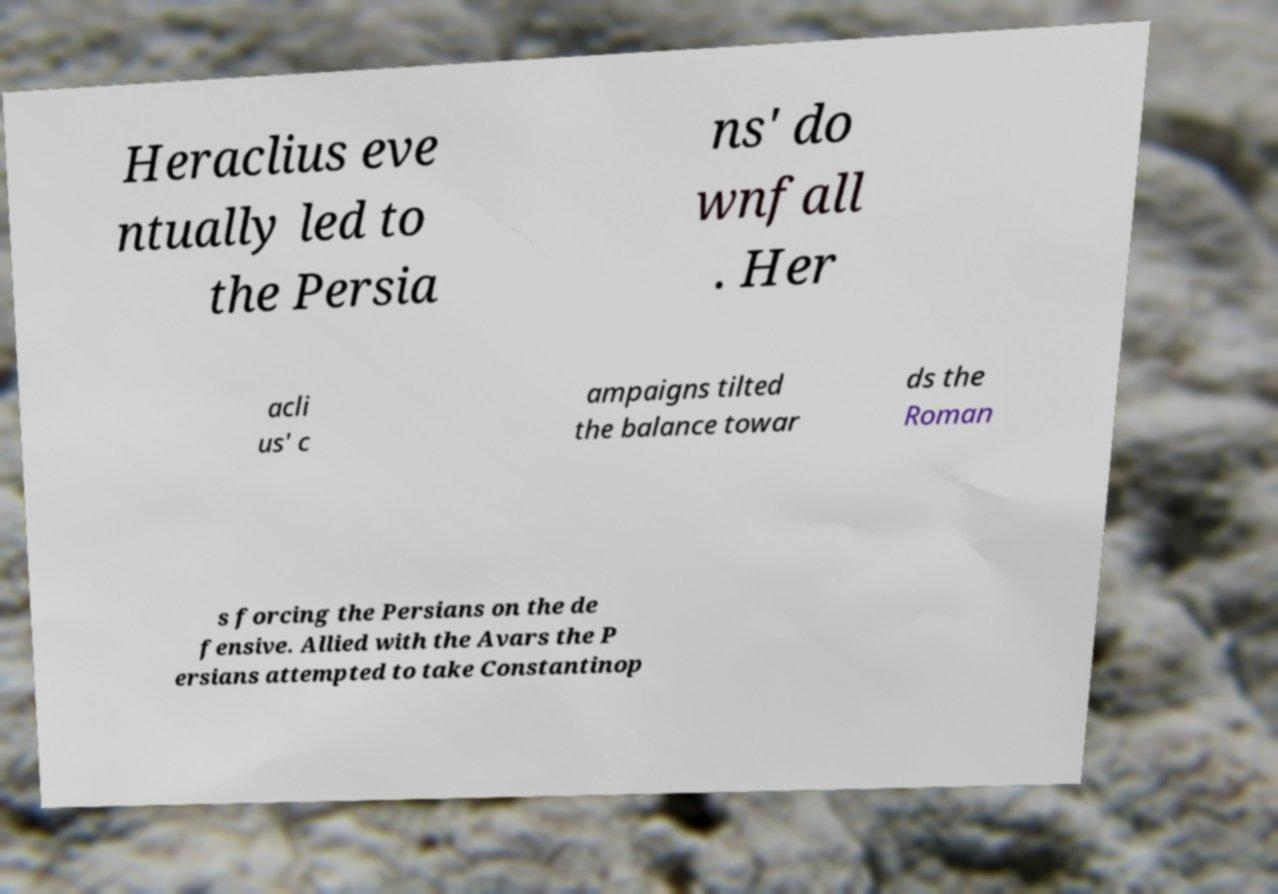Could you extract and type out the text from this image? Heraclius eve ntually led to the Persia ns' do wnfall . Her acli us' c ampaigns tilted the balance towar ds the Roman s forcing the Persians on the de fensive. Allied with the Avars the P ersians attempted to take Constantinop 